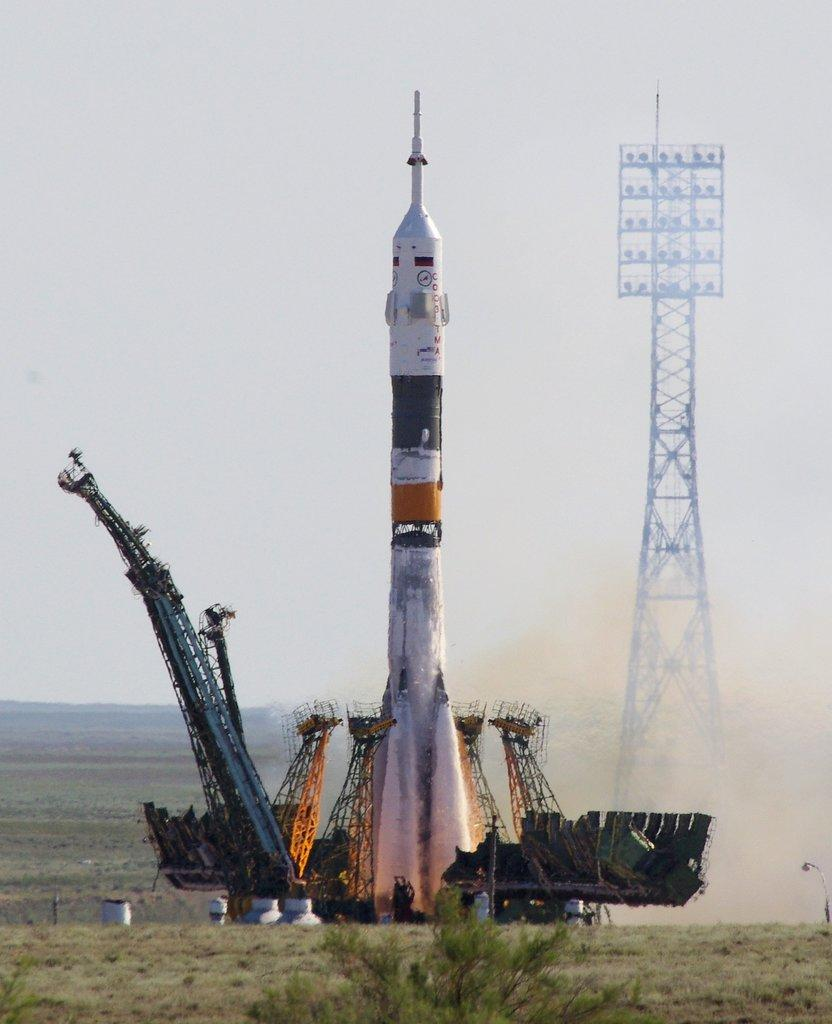What is the main subject of the image? The main subject of the image is a rocket. What is located near the rocket? There is a launch pad in the image. What type of vegetation is at the bottom of the image? There is grass at the bottom of the image. What structure can be seen in the image besides the launch pad? There is a tower in the image. What can be seen in the background of the image? The sky is visible in the background of the image. Where is the scarecrow located in the image? There is no scarecrow present in the image. What type of carriage is used to transport the rocket in the image? There is no carriage present in the image; the rocket is on a launch pad. 